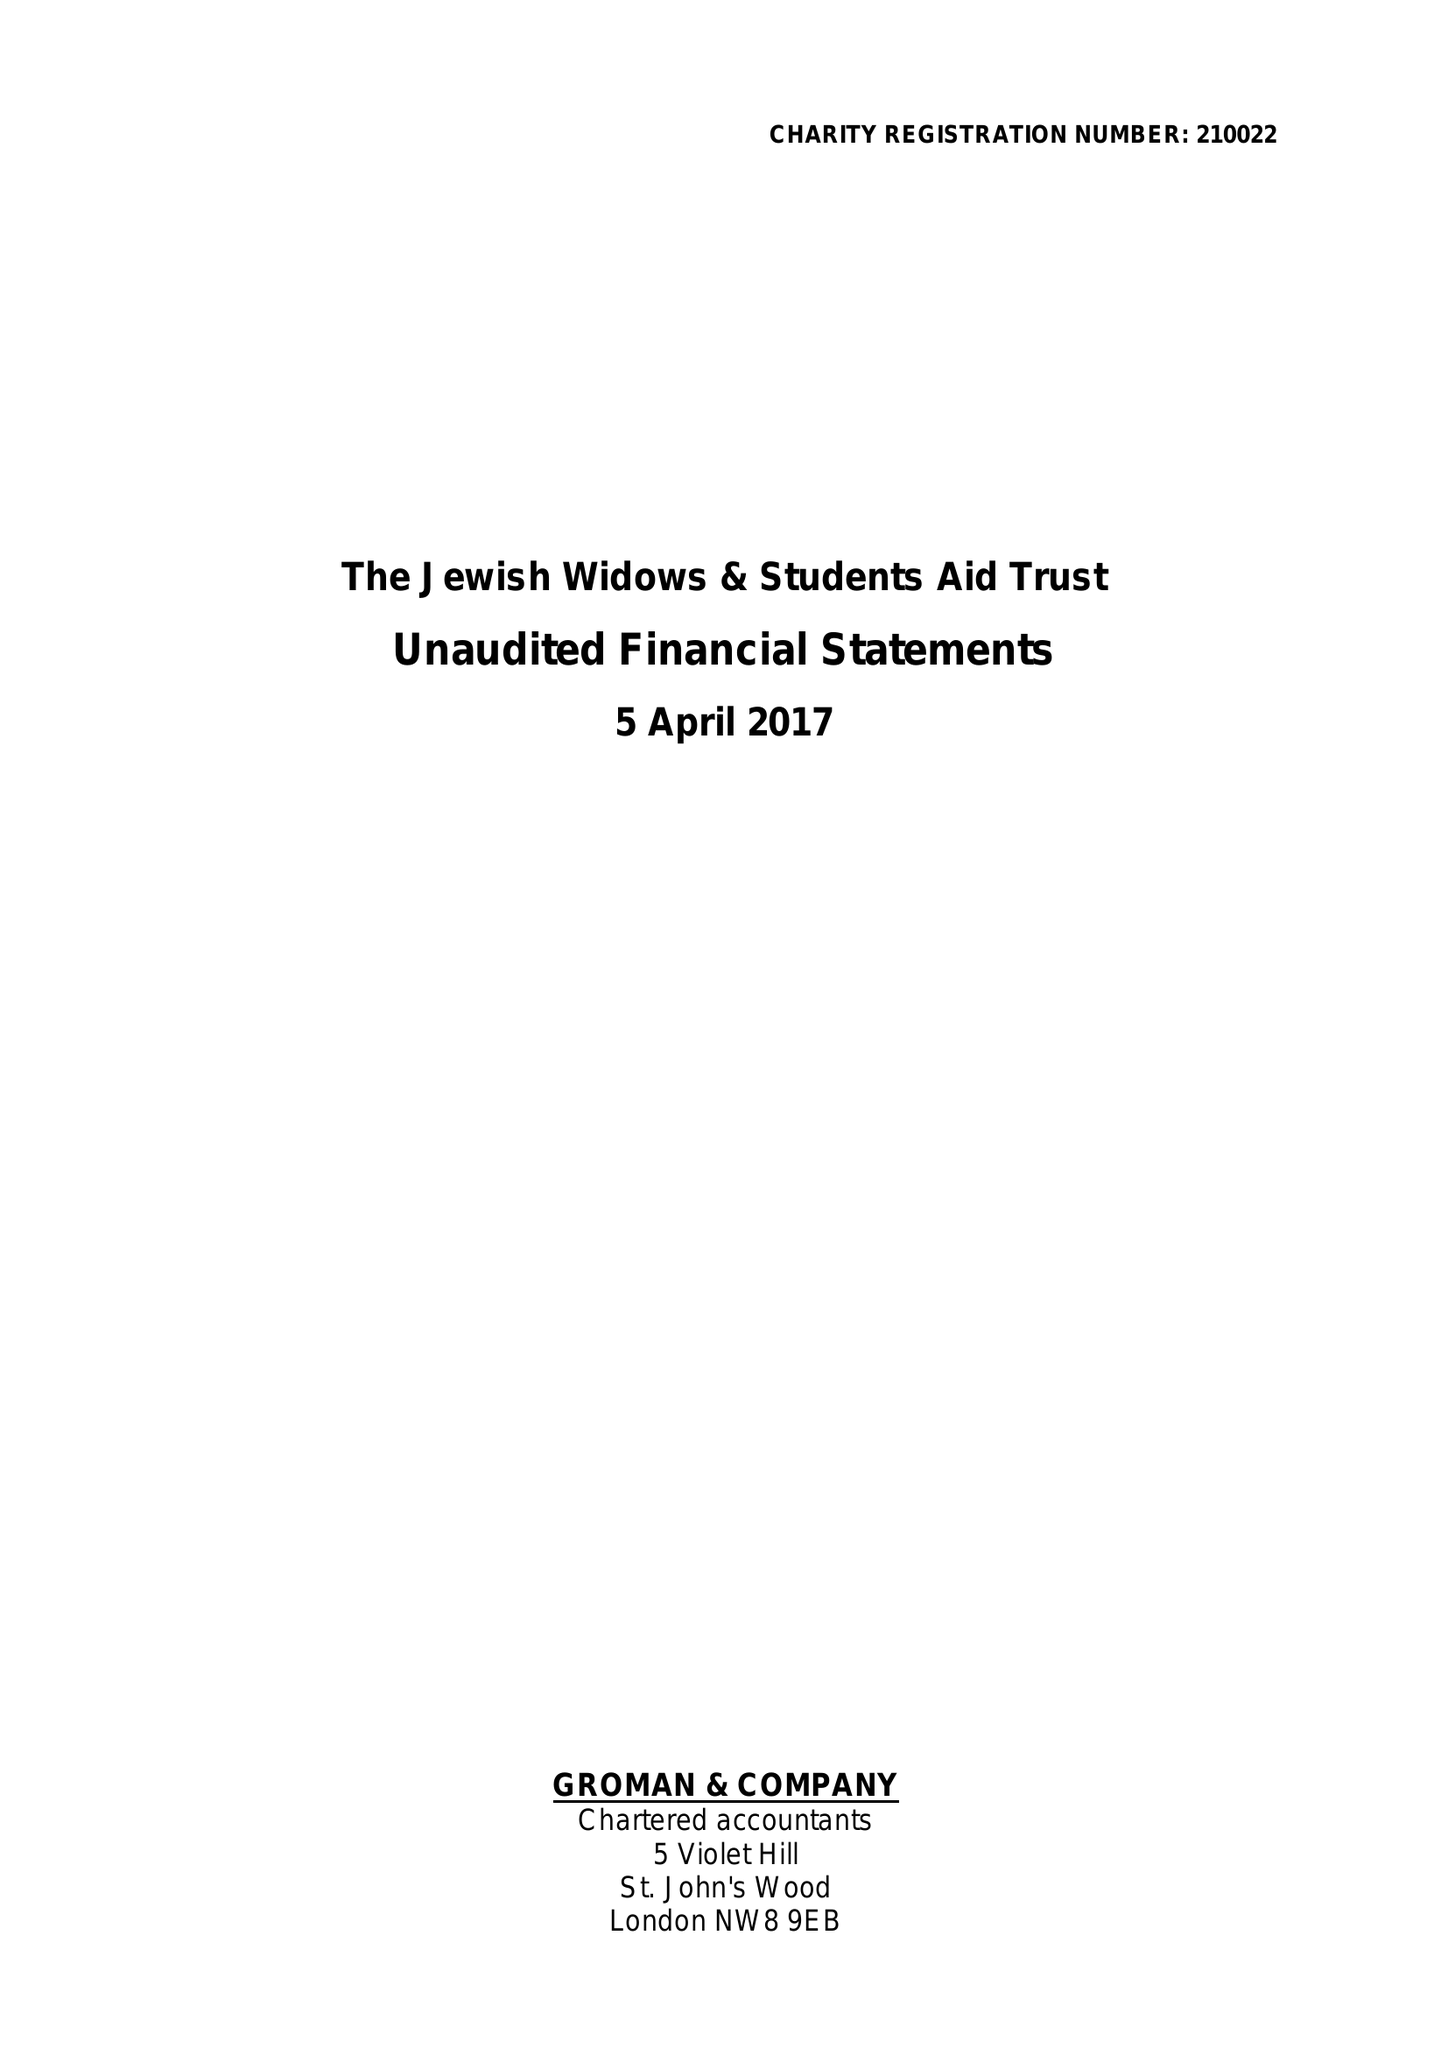What is the value for the report_date?
Answer the question using a single word or phrase. 2017-04-05 